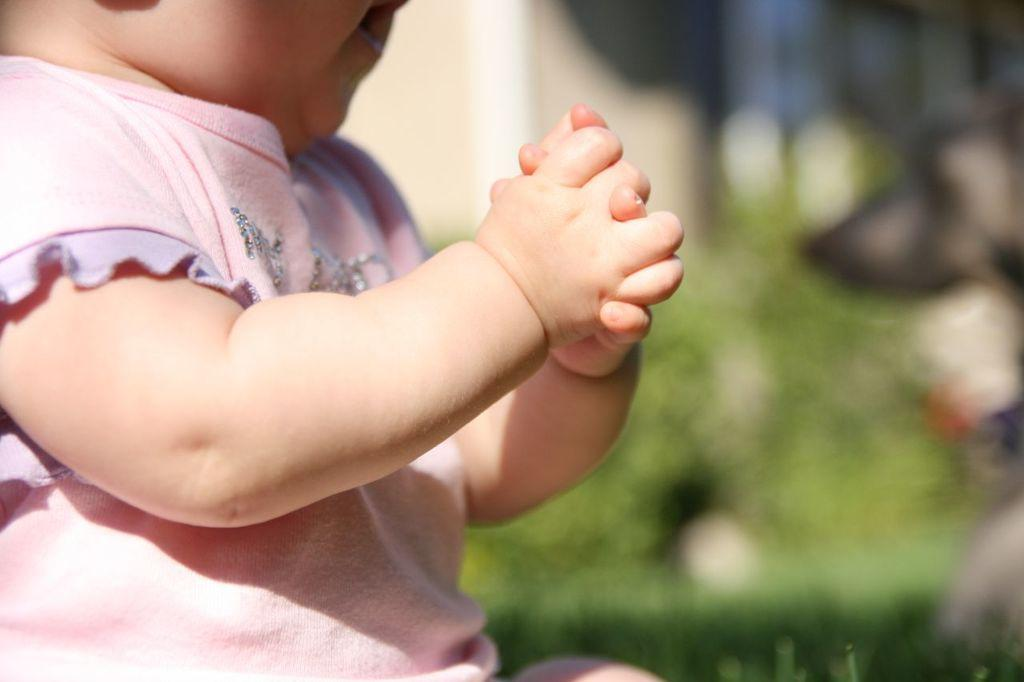What is the main subject of the picture? The main subject of the picture is a baby. What is the baby wearing in the picture? The baby is wearing a pink T-shirt. Can you describe the background of the picture? The background of the picture includes plants, but they are not visible. What type of hope can be seen in the picture? There is no reference to hope in the image, so it is not possible to determine what, if any, hope might be present. 